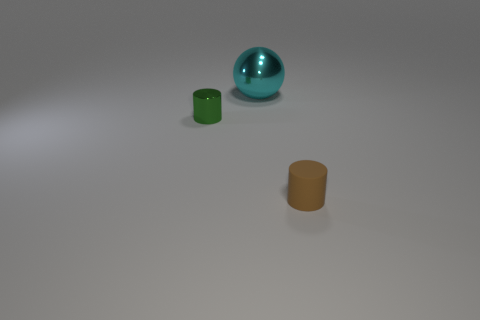What materials might these objects be made of? The sphere looks like it is made of a polished metal due to its reflective surface, while the two cylindrical objects seem to be made of rubber or plastic, characterized by their matte and opaque appearance. 